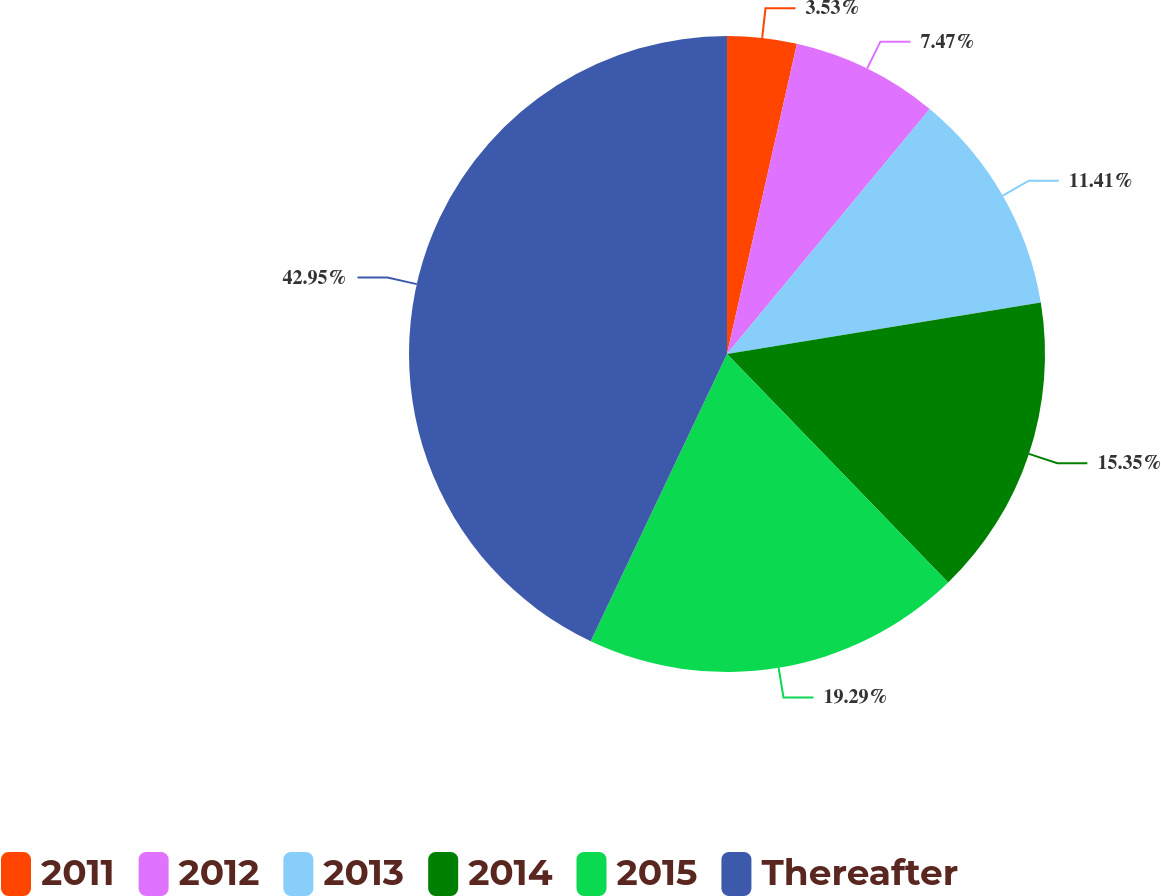Convert chart. <chart><loc_0><loc_0><loc_500><loc_500><pie_chart><fcel>2011<fcel>2012<fcel>2013<fcel>2014<fcel>2015<fcel>Thereafter<nl><fcel>3.53%<fcel>7.47%<fcel>11.41%<fcel>15.35%<fcel>19.29%<fcel>42.95%<nl></chart> 